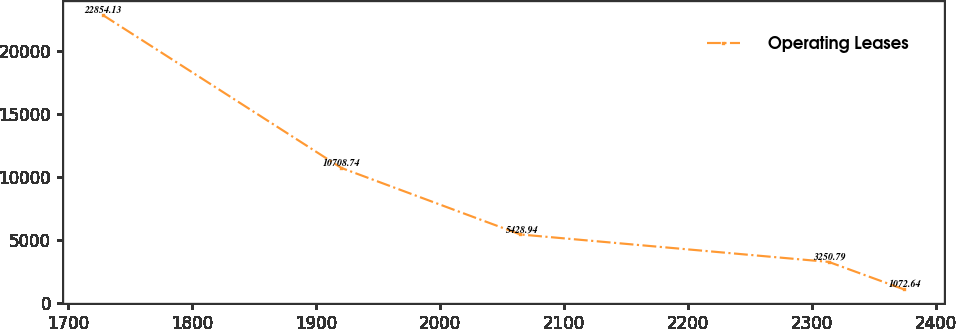Convert chart to OTSL. <chart><loc_0><loc_0><loc_500><loc_500><line_chart><ecel><fcel>Operating Leases<nl><fcel>1727.92<fcel>22854.1<nl><fcel>1920.41<fcel>10708.7<nl><fcel>2064.74<fcel>5428.94<nl><fcel>2313.35<fcel>3250.79<nl><fcel>2373.95<fcel>1072.64<nl></chart> 